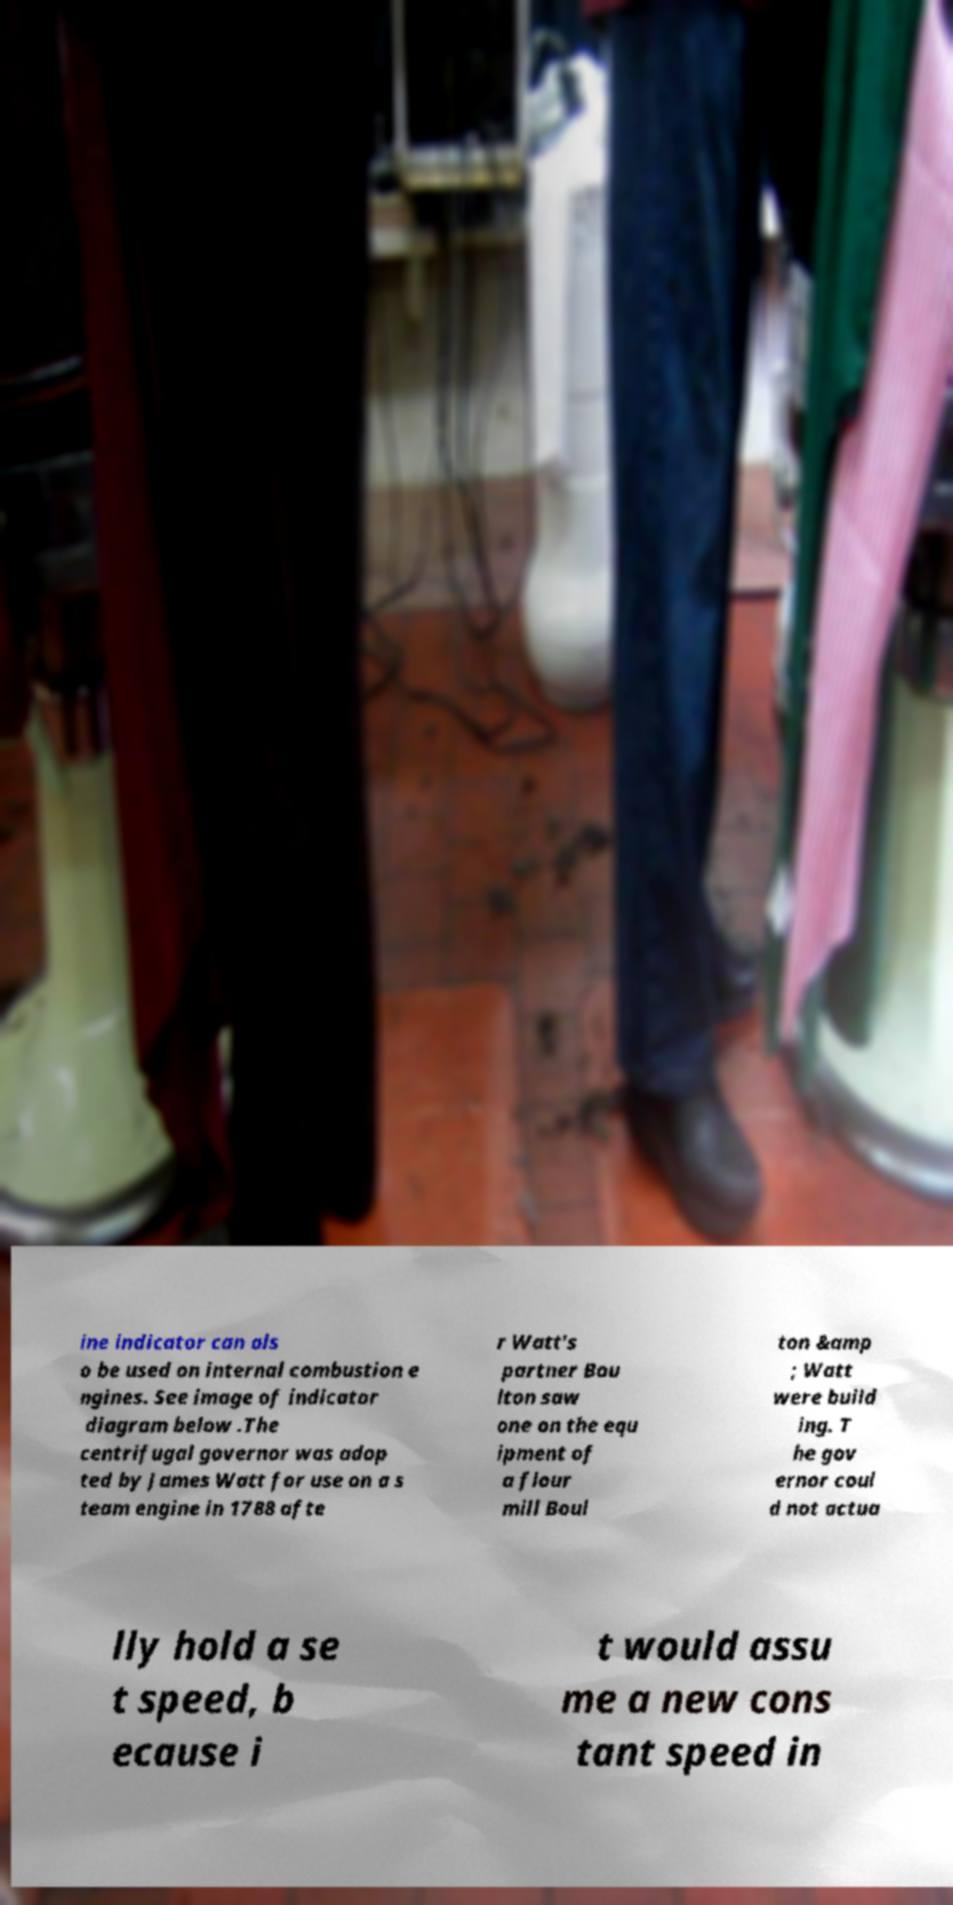Can you read and provide the text displayed in the image?This photo seems to have some interesting text. Can you extract and type it out for me? ine indicator can als o be used on internal combustion e ngines. See image of indicator diagram below .The centrifugal governor was adop ted by James Watt for use on a s team engine in 1788 afte r Watt's partner Bou lton saw one on the equ ipment of a flour mill Boul ton &amp ; Watt were build ing. T he gov ernor coul d not actua lly hold a se t speed, b ecause i t would assu me a new cons tant speed in 